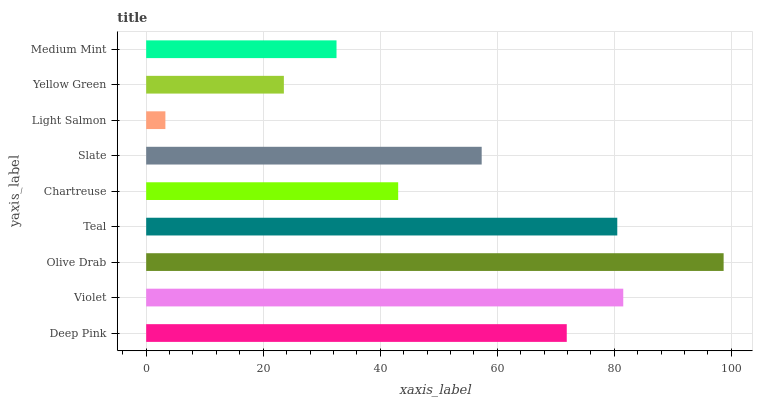Is Light Salmon the minimum?
Answer yes or no. Yes. Is Olive Drab the maximum?
Answer yes or no. Yes. Is Violet the minimum?
Answer yes or no. No. Is Violet the maximum?
Answer yes or no. No. Is Violet greater than Deep Pink?
Answer yes or no. Yes. Is Deep Pink less than Violet?
Answer yes or no. Yes. Is Deep Pink greater than Violet?
Answer yes or no. No. Is Violet less than Deep Pink?
Answer yes or no. No. Is Slate the high median?
Answer yes or no. Yes. Is Slate the low median?
Answer yes or no. Yes. Is Olive Drab the high median?
Answer yes or no. No. Is Light Salmon the low median?
Answer yes or no. No. 